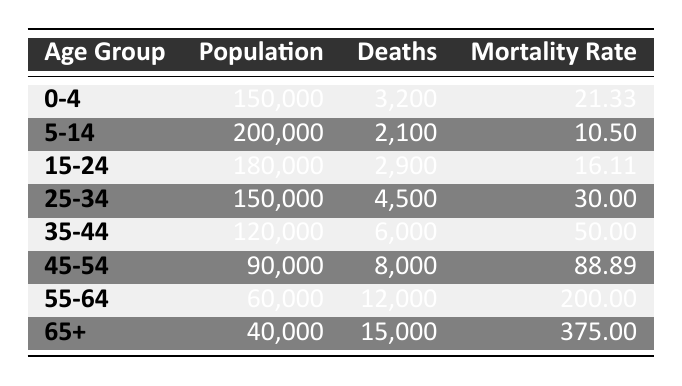What is the mortality rate for the age group 45-54? The table provides a specific entry for the age group 45-54 where the mortality rate is listed directly. Therefore, we can refer to this specific value without further computation.
Answer: 88.89 How many deaths were recorded in the 65+ age group? The number of deaths is explicitly stated in the table for the 65+ age group. By checking this entry, we can find the exact value.
Answer: 15,000 What is the total population of all age groups combined? To find the total population, we need to sum the population of all age groups. Adding them up yields: 150,000 + 200,000 + 180,000 + 150,000 + 120,000 + 90,000 + 60,000 + 40,000 = 1,030,000.
Answer: 1,030,000 Which age group has the highest mortality rate and what is that rate? By examining the mortality rates listed for each age group, we find that the age group 65+ has the highest mortality rate, which is 375.00.
Answer: 65+ age group; 375.00 Is the mortality rate in the 0-4 age group greater than in the 5-14 age group? The mortality rate for the 0-4 age group is 21.33, while for the 5-14 age group it is 10.50. Since 21.33 is greater than 10.50, the statement is true.
Answer: Yes What is the average mortality rate across all age groups? To find the average, we sum the mortality rates: (21.33 + 10.50 + 16.11 + 30.00 + 50.00 + 88.89 + 200.00 + 375.00) = 791.83 and divide by the number of age groups, which is 8. The average is 791.83 / 8 = 98.98.
Answer: 98.98 Are there more deaths in the 55-64 age group than in the 25-34 age group? The deaths in the 55-64 age group are 12,000, while in the 25-34 age group they are 4,500. Since 12,000 is greater than 4,500, the statement is true.
Answer: Yes What is the total number of deaths from the age group 35-44 and older? To find the total deaths from the age group 35-44 and older, we add the deaths in the ranges 35-44 (6,000), 45-54 (8,000), 55-64 (12,000), and 65+ (15,000). Calculating this gives us a total of 6,000 + 8,000 + 12,000 + 15,000 = 41,000.
Answer: 41,000 Which age group has the smallest population? By examining the population figures for each age group, we see that the age group 65+ has the smallest population at 40,000.
Answer: 65+ age group What is the difference in mortality rates between the age groups 25-34 and 35-44? The mortality rate for the age group 25-34 is 30.00, and for 35-44 it is 50.00. Calculating the difference gives us 50.00 - 30.00 = 20.00.
Answer: 20.00 